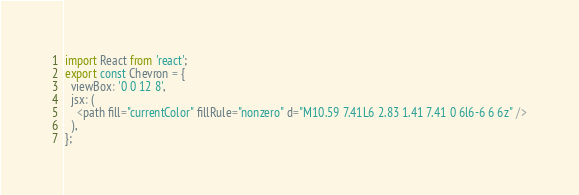<code> <loc_0><loc_0><loc_500><loc_500><_TypeScript_>import React from 'react';
export const Chevron = {
  viewBox: '0 0 12 8',
  jsx: (
    <path fill="currentColor" fillRule="nonzero" d="M10.59 7.41L6 2.83 1.41 7.41 0 6l6-6 6 6z" />
  ),
};
</code> 